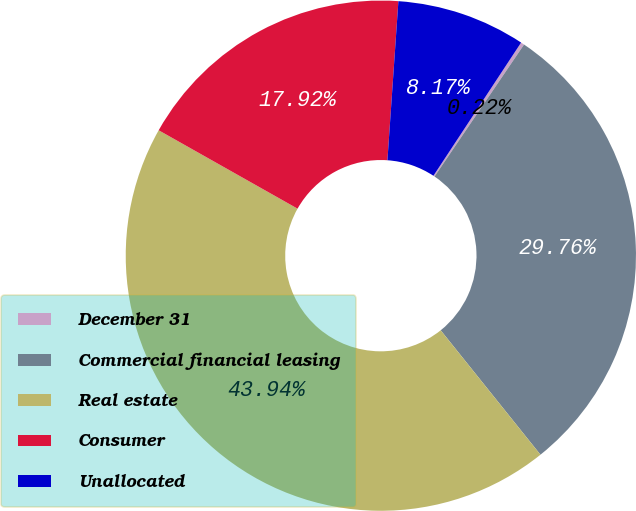Convert chart. <chart><loc_0><loc_0><loc_500><loc_500><pie_chart><fcel>December 31<fcel>Commercial financial leasing<fcel>Real estate<fcel>Consumer<fcel>Unallocated<nl><fcel>0.22%<fcel>29.76%<fcel>43.94%<fcel>17.92%<fcel>8.17%<nl></chart> 